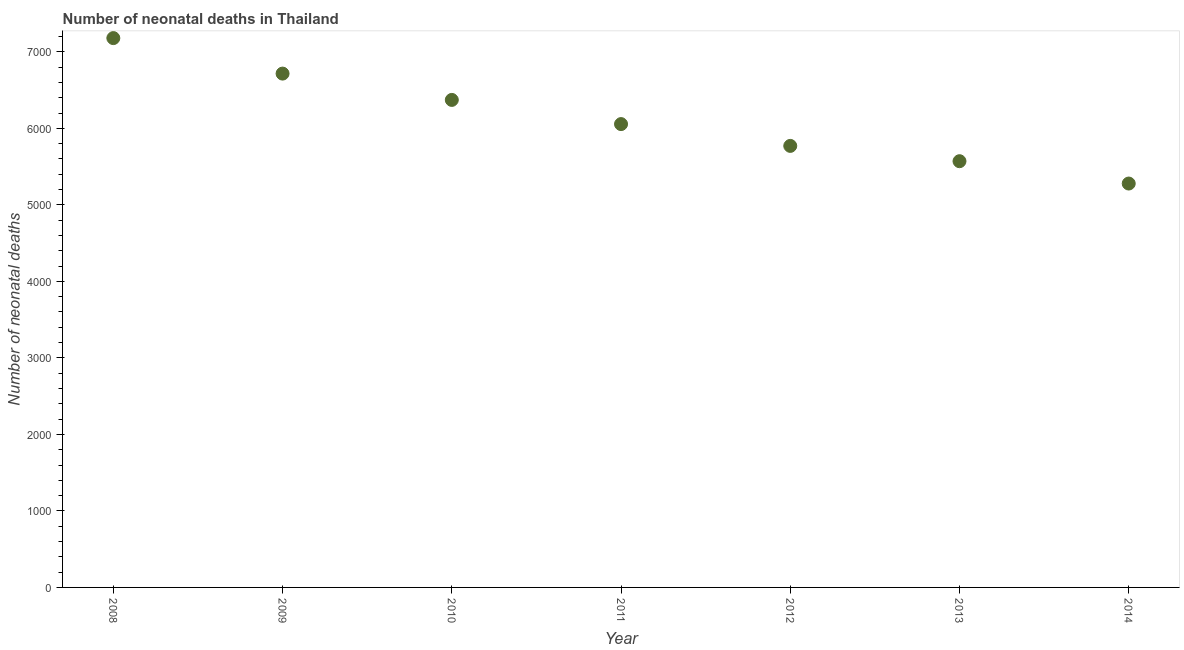What is the number of neonatal deaths in 2012?
Offer a very short reply. 5771. Across all years, what is the maximum number of neonatal deaths?
Give a very brief answer. 7180. Across all years, what is the minimum number of neonatal deaths?
Offer a terse response. 5279. What is the sum of the number of neonatal deaths?
Your answer should be compact. 4.29e+04. What is the difference between the number of neonatal deaths in 2013 and 2014?
Make the answer very short. 292. What is the average number of neonatal deaths per year?
Your answer should be compact. 6135. What is the median number of neonatal deaths?
Your answer should be very brief. 6056. In how many years, is the number of neonatal deaths greater than 6800 ?
Make the answer very short. 1. Do a majority of the years between 2009 and 2010 (inclusive) have number of neonatal deaths greater than 3600 ?
Keep it short and to the point. Yes. What is the ratio of the number of neonatal deaths in 2009 to that in 2010?
Your response must be concise. 1.05. Is the number of neonatal deaths in 2011 less than that in 2012?
Your response must be concise. No. What is the difference between the highest and the second highest number of neonatal deaths?
Give a very brief answer. 464. What is the difference between the highest and the lowest number of neonatal deaths?
Offer a very short reply. 1901. Does the number of neonatal deaths monotonically increase over the years?
Offer a terse response. No. How many years are there in the graph?
Give a very brief answer. 7. Does the graph contain grids?
Offer a very short reply. No. What is the title of the graph?
Your response must be concise. Number of neonatal deaths in Thailand. What is the label or title of the X-axis?
Provide a succinct answer. Year. What is the label or title of the Y-axis?
Offer a terse response. Number of neonatal deaths. What is the Number of neonatal deaths in 2008?
Give a very brief answer. 7180. What is the Number of neonatal deaths in 2009?
Keep it short and to the point. 6716. What is the Number of neonatal deaths in 2010?
Offer a terse response. 6372. What is the Number of neonatal deaths in 2011?
Your answer should be compact. 6056. What is the Number of neonatal deaths in 2012?
Offer a very short reply. 5771. What is the Number of neonatal deaths in 2013?
Keep it short and to the point. 5571. What is the Number of neonatal deaths in 2014?
Make the answer very short. 5279. What is the difference between the Number of neonatal deaths in 2008 and 2009?
Keep it short and to the point. 464. What is the difference between the Number of neonatal deaths in 2008 and 2010?
Offer a very short reply. 808. What is the difference between the Number of neonatal deaths in 2008 and 2011?
Give a very brief answer. 1124. What is the difference between the Number of neonatal deaths in 2008 and 2012?
Offer a very short reply. 1409. What is the difference between the Number of neonatal deaths in 2008 and 2013?
Your response must be concise. 1609. What is the difference between the Number of neonatal deaths in 2008 and 2014?
Ensure brevity in your answer.  1901. What is the difference between the Number of neonatal deaths in 2009 and 2010?
Make the answer very short. 344. What is the difference between the Number of neonatal deaths in 2009 and 2011?
Your response must be concise. 660. What is the difference between the Number of neonatal deaths in 2009 and 2012?
Your response must be concise. 945. What is the difference between the Number of neonatal deaths in 2009 and 2013?
Provide a succinct answer. 1145. What is the difference between the Number of neonatal deaths in 2009 and 2014?
Keep it short and to the point. 1437. What is the difference between the Number of neonatal deaths in 2010 and 2011?
Provide a short and direct response. 316. What is the difference between the Number of neonatal deaths in 2010 and 2012?
Your answer should be very brief. 601. What is the difference between the Number of neonatal deaths in 2010 and 2013?
Offer a terse response. 801. What is the difference between the Number of neonatal deaths in 2010 and 2014?
Offer a terse response. 1093. What is the difference between the Number of neonatal deaths in 2011 and 2012?
Your response must be concise. 285. What is the difference between the Number of neonatal deaths in 2011 and 2013?
Provide a succinct answer. 485. What is the difference between the Number of neonatal deaths in 2011 and 2014?
Your answer should be compact. 777. What is the difference between the Number of neonatal deaths in 2012 and 2013?
Make the answer very short. 200. What is the difference between the Number of neonatal deaths in 2012 and 2014?
Offer a terse response. 492. What is the difference between the Number of neonatal deaths in 2013 and 2014?
Your answer should be compact. 292. What is the ratio of the Number of neonatal deaths in 2008 to that in 2009?
Your answer should be very brief. 1.07. What is the ratio of the Number of neonatal deaths in 2008 to that in 2010?
Your response must be concise. 1.13. What is the ratio of the Number of neonatal deaths in 2008 to that in 2011?
Ensure brevity in your answer.  1.19. What is the ratio of the Number of neonatal deaths in 2008 to that in 2012?
Provide a short and direct response. 1.24. What is the ratio of the Number of neonatal deaths in 2008 to that in 2013?
Provide a short and direct response. 1.29. What is the ratio of the Number of neonatal deaths in 2008 to that in 2014?
Offer a terse response. 1.36. What is the ratio of the Number of neonatal deaths in 2009 to that in 2010?
Make the answer very short. 1.05. What is the ratio of the Number of neonatal deaths in 2009 to that in 2011?
Offer a very short reply. 1.11. What is the ratio of the Number of neonatal deaths in 2009 to that in 2012?
Offer a very short reply. 1.16. What is the ratio of the Number of neonatal deaths in 2009 to that in 2013?
Keep it short and to the point. 1.21. What is the ratio of the Number of neonatal deaths in 2009 to that in 2014?
Provide a succinct answer. 1.27. What is the ratio of the Number of neonatal deaths in 2010 to that in 2011?
Your response must be concise. 1.05. What is the ratio of the Number of neonatal deaths in 2010 to that in 2012?
Ensure brevity in your answer.  1.1. What is the ratio of the Number of neonatal deaths in 2010 to that in 2013?
Your answer should be very brief. 1.14. What is the ratio of the Number of neonatal deaths in 2010 to that in 2014?
Make the answer very short. 1.21. What is the ratio of the Number of neonatal deaths in 2011 to that in 2012?
Keep it short and to the point. 1.05. What is the ratio of the Number of neonatal deaths in 2011 to that in 2013?
Keep it short and to the point. 1.09. What is the ratio of the Number of neonatal deaths in 2011 to that in 2014?
Offer a terse response. 1.15. What is the ratio of the Number of neonatal deaths in 2012 to that in 2013?
Offer a very short reply. 1.04. What is the ratio of the Number of neonatal deaths in 2012 to that in 2014?
Make the answer very short. 1.09. What is the ratio of the Number of neonatal deaths in 2013 to that in 2014?
Provide a short and direct response. 1.05. 